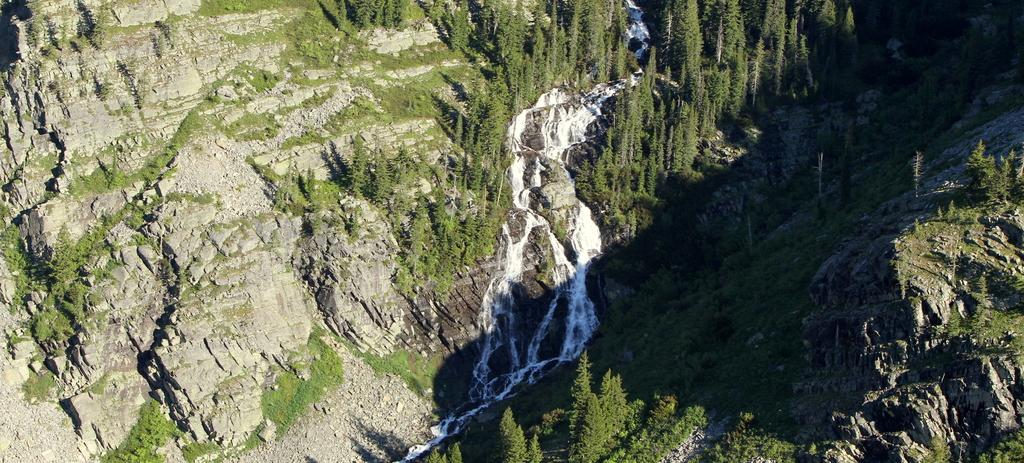What is the main feature in the foreground of the image? There is a river flowing in the foreground of the image. What type of vegetation can be seen near the river? Trees are present on either side of the river. What geographical feature is visible on both sides of the river? Mountains are placed on either side of the river. What type of plastic material can be seen floating in the river? There is no plastic material visible in the river in the image. 